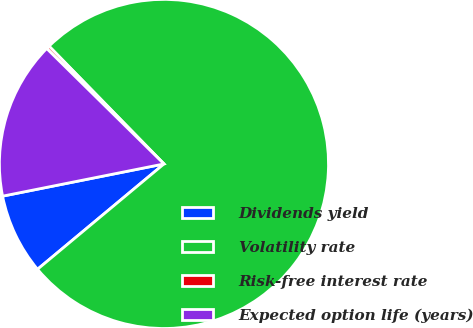Convert chart to OTSL. <chart><loc_0><loc_0><loc_500><loc_500><pie_chart><fcel>Dividends yield<fcel>Volatility rate<fcel>Risk-free interest rate<fcel>Expected option life (years)<nl><fcel>7.92%<fcel>76.25%<fcel>0.32%<fcel>15.51%<nl></chart> 